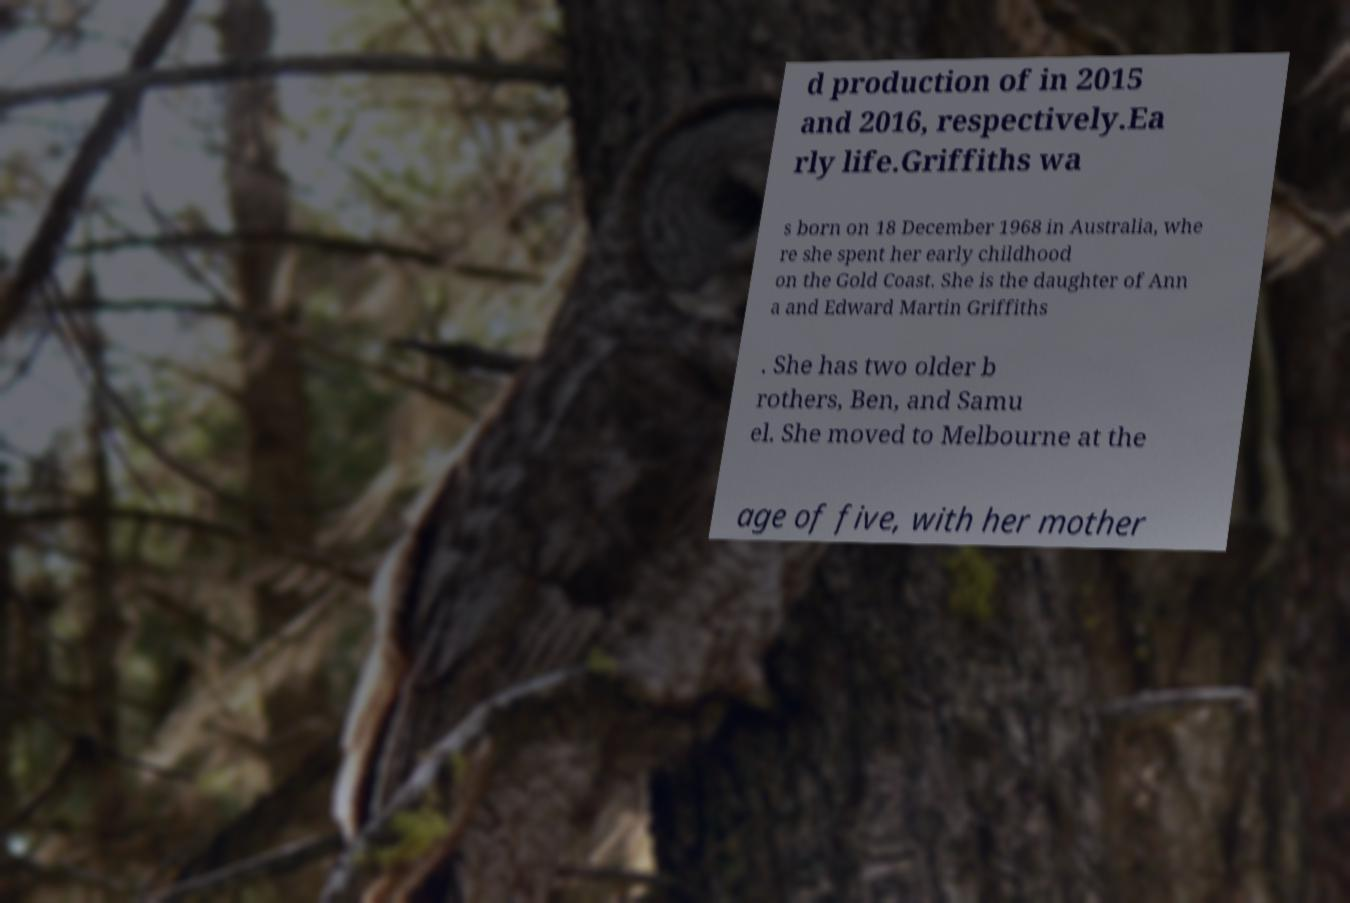Could you assist in decoding the text presented in this image and type it out clearly? d production of in 2015 and 2016, respectively.Ea rly life.Griffiths wa s born on 18 December 1968 in Australia, whe re she spent her early childhood on the Gold Coast. She is the daughter of Ann a and Edward Martin Griffiths . She has two older b rothers, Ben, and Samu el. She moved to Melbourne at the age of five, with her mother 